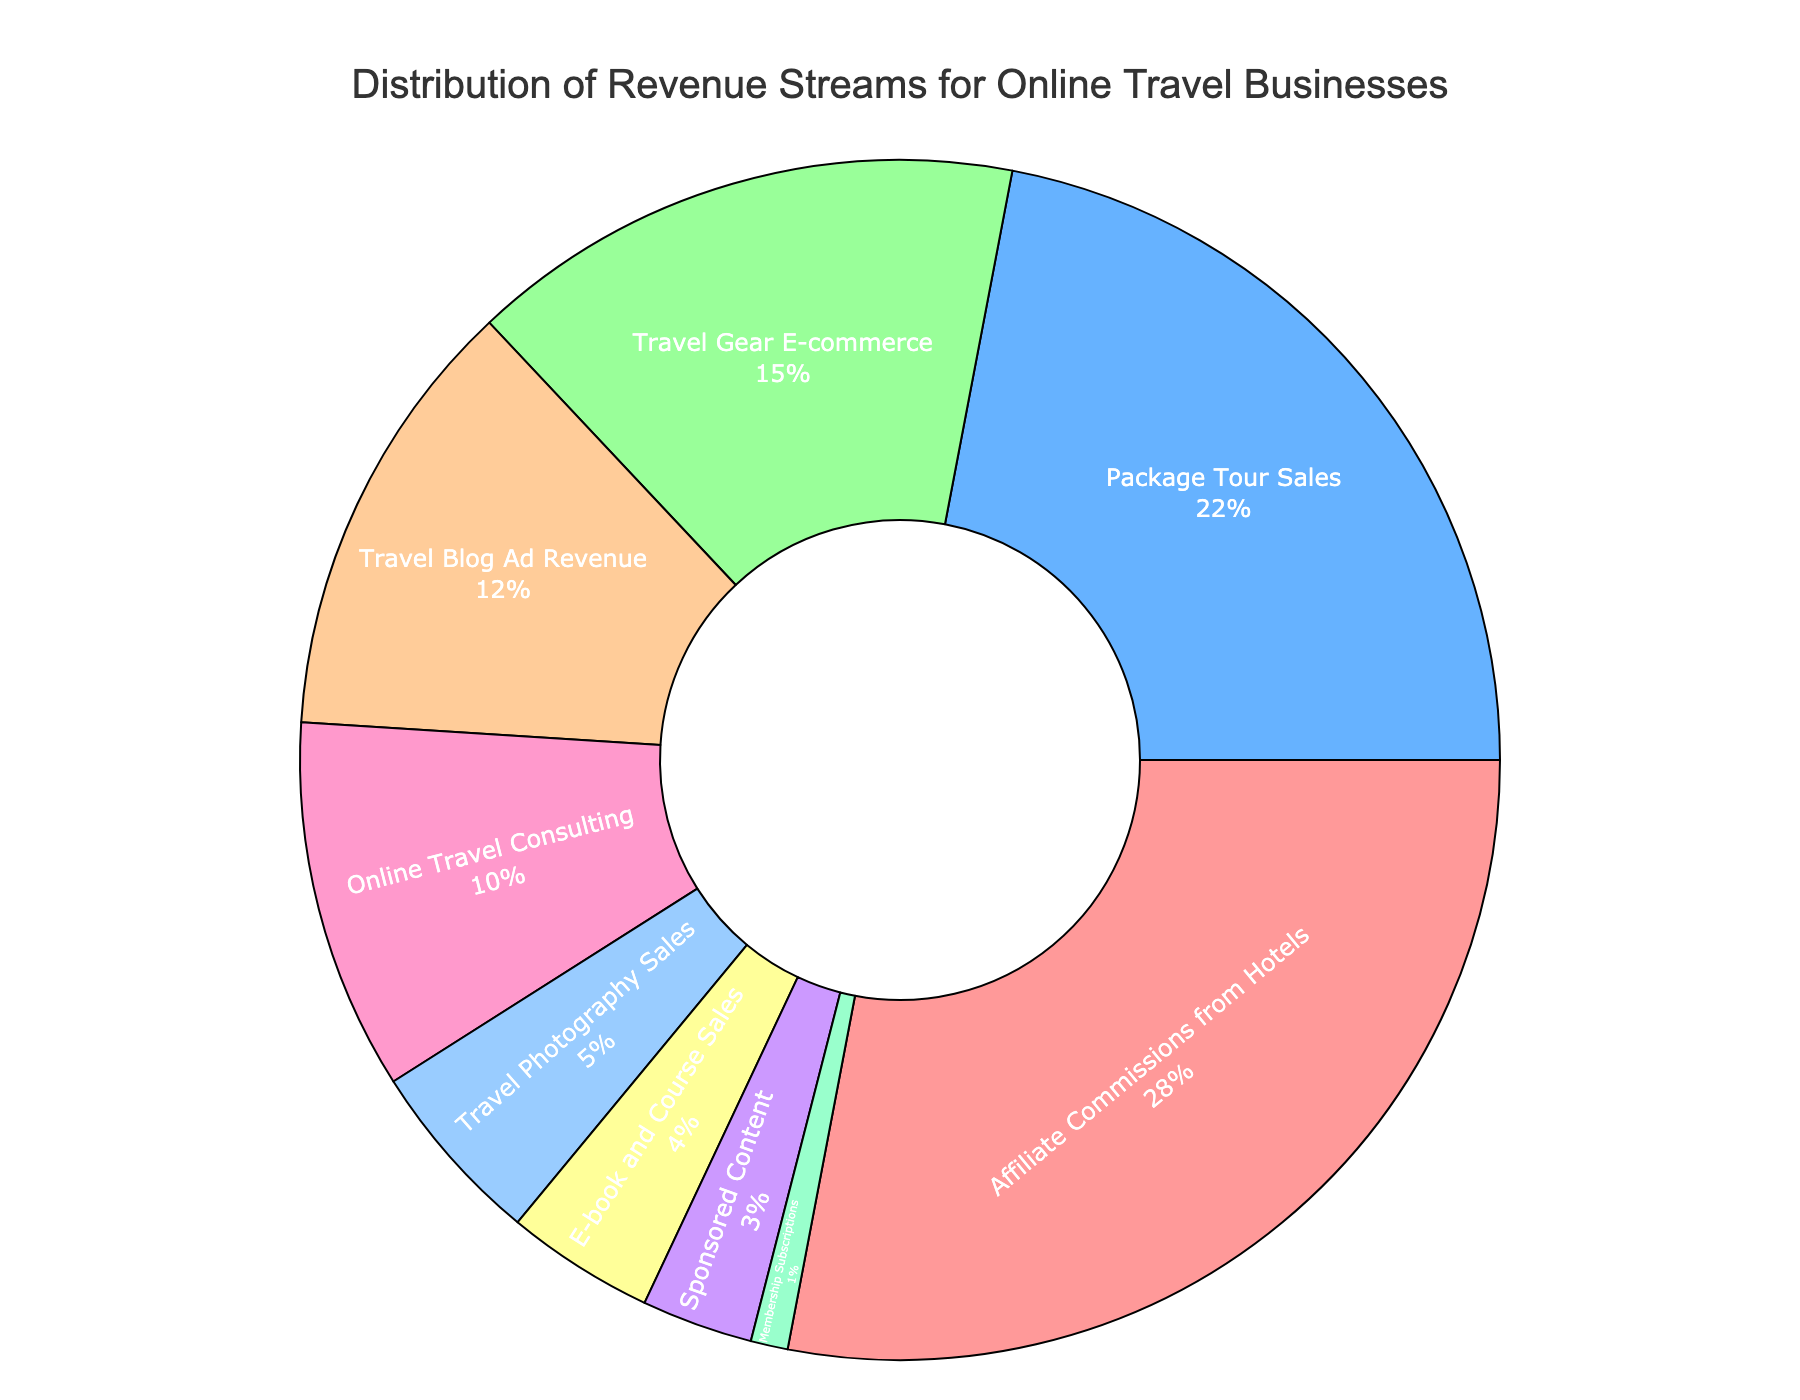What revenue stream has the highest percentage? Look at the section of the pie chart with the largest area; it corresponds to the revenue stream with the highest percentage. Identify the label and percentage in that section.
Answer: Affiliate Commissions from Hotels Which revenue stream has the smallest contribution? Find the smallest segment in the pie chart and note the corresponding label and percentage.
Answer: Membership Subscriptions What percentage of revenue comes from online travel consulting and travel blog ad revenue combined? Add the percentages for online travel consulting (10%) and travel blog ad revenue (12%).
Answer: 22% Is the percentage contribution from travel photography sales greater than or less than that from e-book and course sales? Compare the percentages for travel photography sales (5%) and e-book and course sales (4%).
Answer: Greater than How does the percentage of package tour sales compare to the percentage of travel blog ad revenue and online travel consulting combined? Calculate the sum of travel blog ad revenue (12%) and online travel consulting (10%), then compare this total (22%) to the percentage of package tour sales (22%).
Answer: Equal to What are the revenue streams that contribute at least 10% each? Identify and list the segments of the pie chart where the percentages are 10% or higher.
Answer: Affiliate Commissions from Hotels, Package Tour Sales, Travel Blog Ad Revenue, Online Travel Consulting Which color represents the revenue stream with the lowest contribution? Identify the smallest segment in the pie chart and note its corresponding color.
Answer: Light green (Membership Subscriptions) Is the combined revenue from travel gear e-commerce and travel photography sales greater or less than the revenue from package tour sales alone? Add the percentages for travel gear e-commerce (15%) and travel photography sales (5%), then compare this total (20%) to the percentage for package tour sales (22%).
Answer: Less than What is the total percentage of revenue from streams with individual contributions less than 5%? Identify segments with percentages less than 5%, sum their percentages: only Membership Subscriptions (1%).
Answer: 1% 